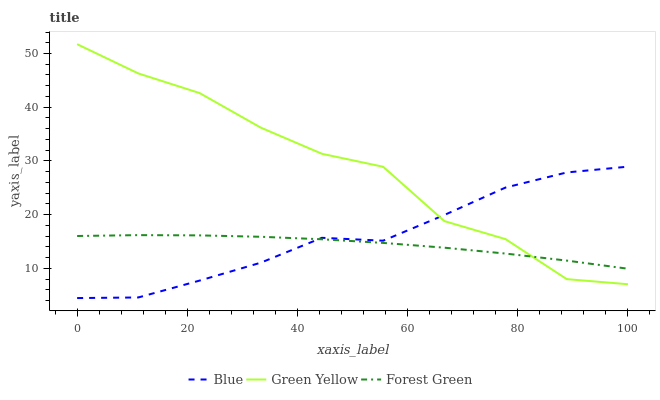Does Green Yellow have the minimum area under the curve?
Answer yes or no. No. Does Forest Green have the maximum area under the curve?
Answer yes or no. No. Is Green Yellow the smoothest?
Answer yes or no. No. Is Forest Green the roughest?
Answer yes or no. No. Does Green Yellow have the lowest value?
Answer yes or no. No. Does Forest Green have the highest value?
Answer yes or no. No. 